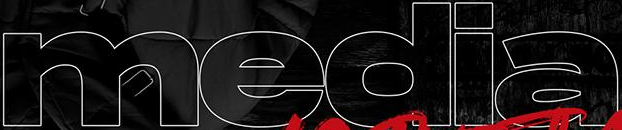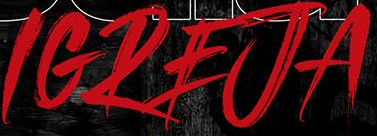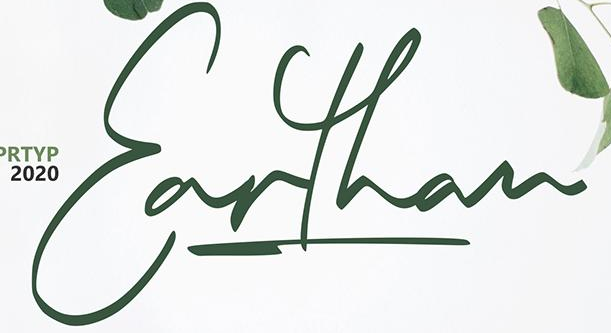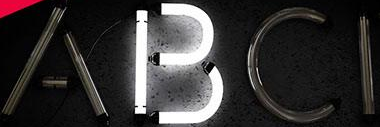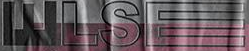What words are shown in these images in order, separated by a semicolon? media; IGREJA; Earthan; ABCI; WLSE 